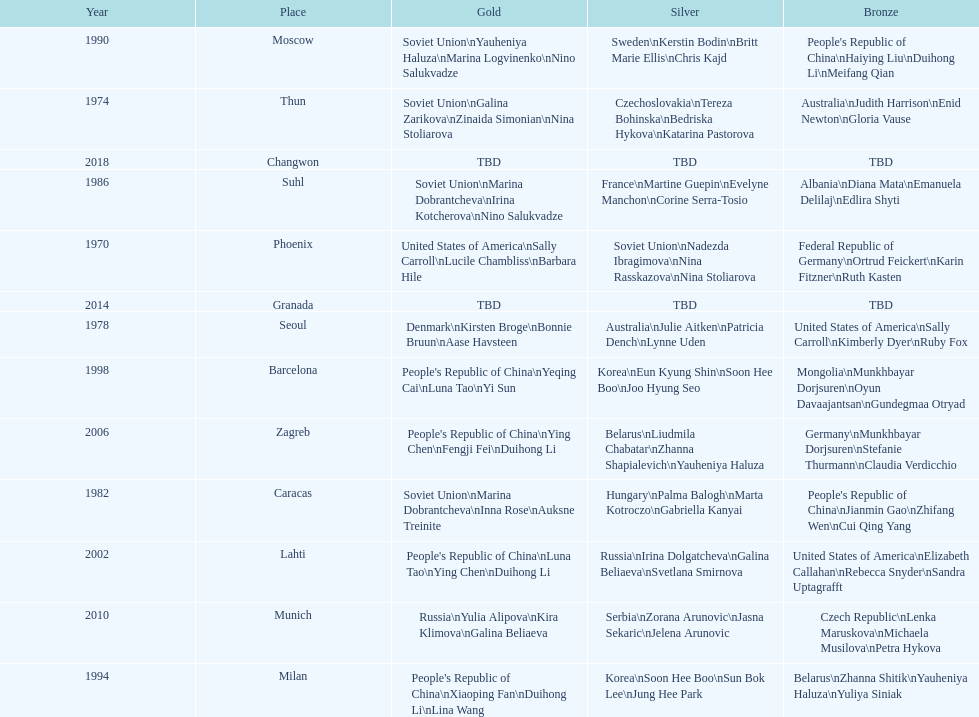What is the first place listed in this chart? Phoenix. 